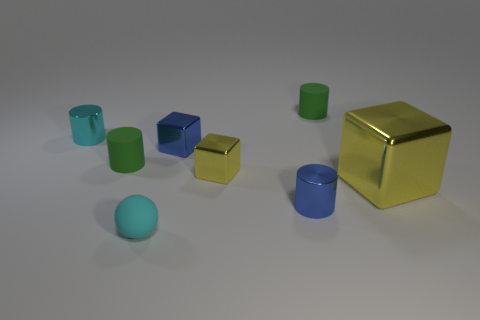The metal thing that is to the left of the green cylinder in front of the green matte object that is behind the blue shiny block is what color?
Your answer should be compact. Cyan. Is the size of the cyan metal cylinder the same as the matte ball?
Ensure brevity in your answer.  Yes. How many balls have the same size as the cyan shiny thing?
Your response must be concise. 1. There is another shiny object that is the same color as the large shiny object; what is its shape?
Ensure brevity in your answer.  Cube. Is the material of the green object that is to the right of the tiny sphere the same as the small cylinder that is in front of the large metallic block?
Keep it short and to the point. No. Are there any other things that have the same shape as the tiny cyan shiny object?
Offer a terse response. Yes. What color is the large shiny object?
Offer a terse response. Yellow. How many rubber things have the same shape as the large yellow metallic thing?
Offer a terse response. 0. What is the color of the ball that is the same size as the blue metallic cylinder?
Your answer should be very brief. Cyan. Are there any blue blocks?
Your answer should be compact. Yes. 